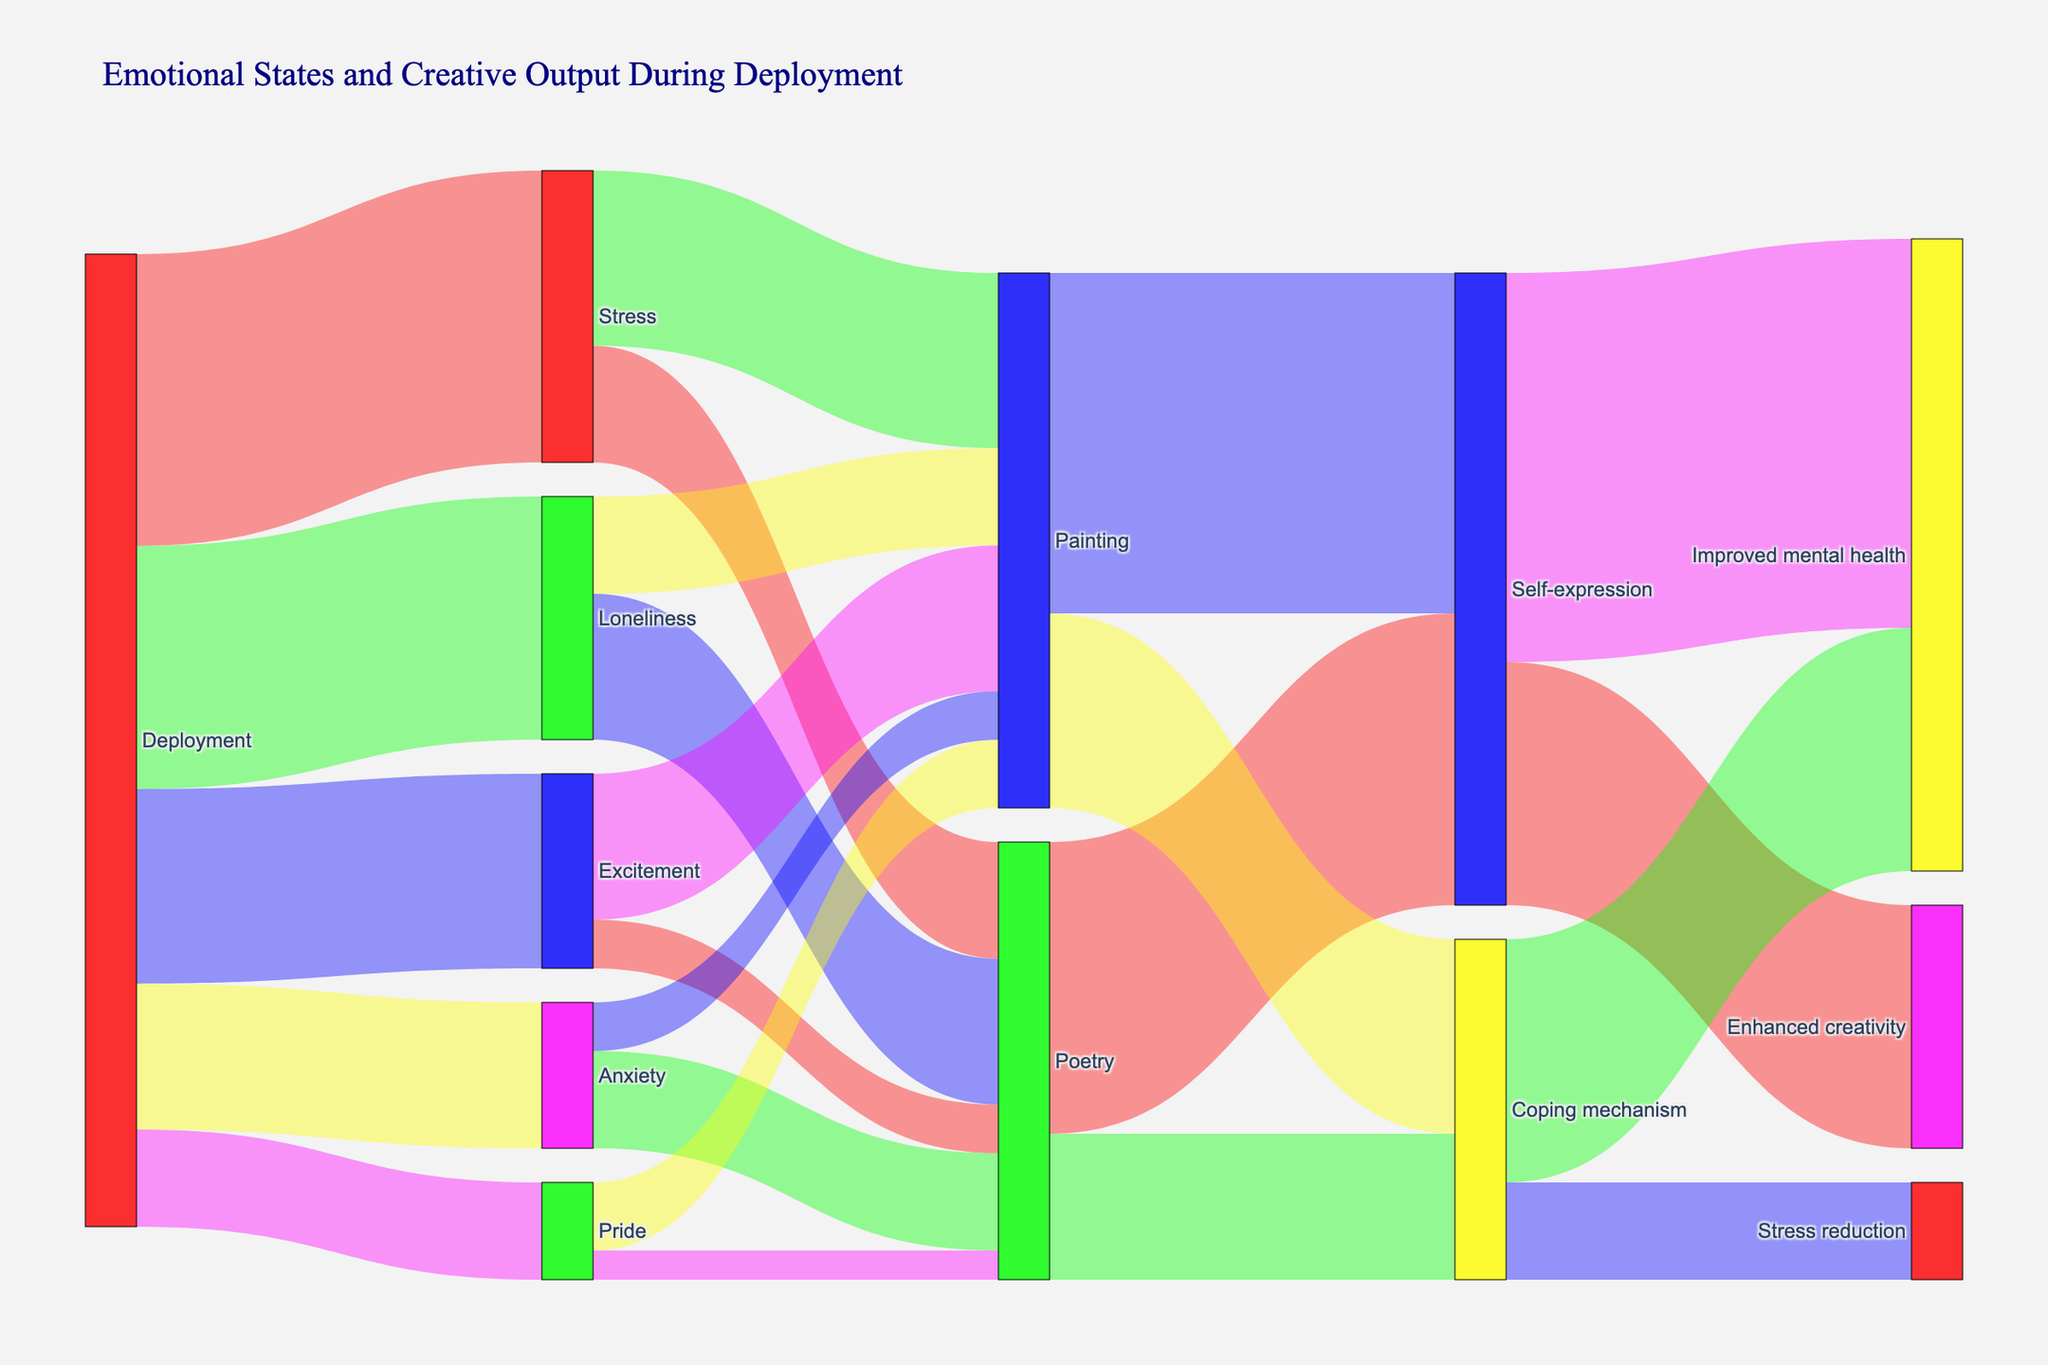What is the title of the Sankey diagram? The title is prominently displayed at the top of the diagram. Reading that title will give us the required information.
Answer: "Emotional States and Creative Output During Deployment" How many emotional states are linked directly from the deployment phase? By looking at the left side of the diagram, we see which nodes are connected to "Deployment". Count these direct links.
Answer: 5 Which creative output received the most influence from the emotional state of Stress? By tracing the connections from "Stress" to its targets, you can identify which creative output has the highest value. Compare the values for Poetry and Painting linked to Stress.
Answer: Painting What is the total value of the emotional states linked to the deployment phase? Sum the values of all the emotional states connected to the "Deployment" node. Calculation is: 30 (Stress) + 25 (Loneliness) + 20 (Excitement) + 15 (Anxiety) + 10 (Pride) = 100
Answer: 100 Which condition has a higher value: Improved mental health from Self-expression or Coping mechanism? Follow the connections from Self-expression and Coping mechanism to Improved mental health and compare the values. Self-expression connects with a value of 40 while Coping mechanism connects with a value of 25.
Answer: Self-expression Which emotional state contributes more to Painting: Excitement or Loneliness? Follow the links from "Excitement" and "Loneliness" to "Painting" and compare their values.
Answer: Excitement How do Pride's contributions split between Poetry and Painting? Observe the links from "Pride" and note the values connecting to "Poetry" and "Painting".
Answer: Poetry: 3, Painting: 7 Which creative output is more commonly used as a coping mechanism? Follow the links from "Poetry" and "Painting" to "Coping mechanism" and compare the values.
Answer: Painting What is the total value of outputs leading to Enhanced creativity? Sum the values of links directed to "Enhanced creativity". Calculation: 25 (from Self-expression) = 25
Answer: 25 What is more influential in reducing stress: Poetry or Painting? Follow the links connected to "Stress reduction" and compare whether "Poetry" or "Painting" has a higher collective value leading to that target. Note that "Stress reduction" only connects via paths originating from coping mechanisms of Painting.
Answer: Painting 